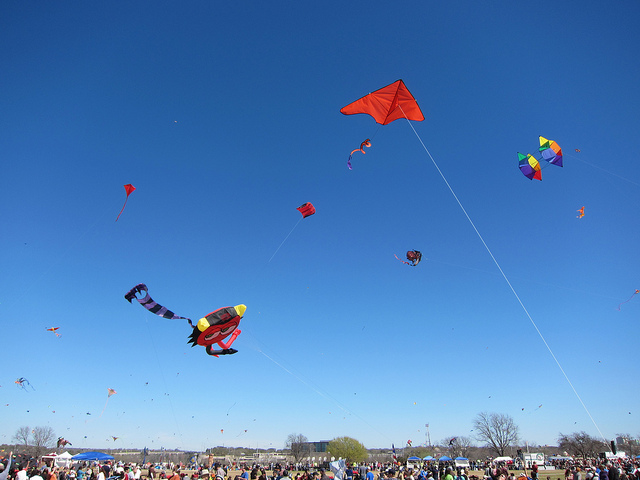<image>What animal is the pink kite? I don't know. There seems to be no pink kite in the image. However, if there is one, it could possibly be a bird or a cat. What animal is the pink kite? There is no pink kite in the image. 